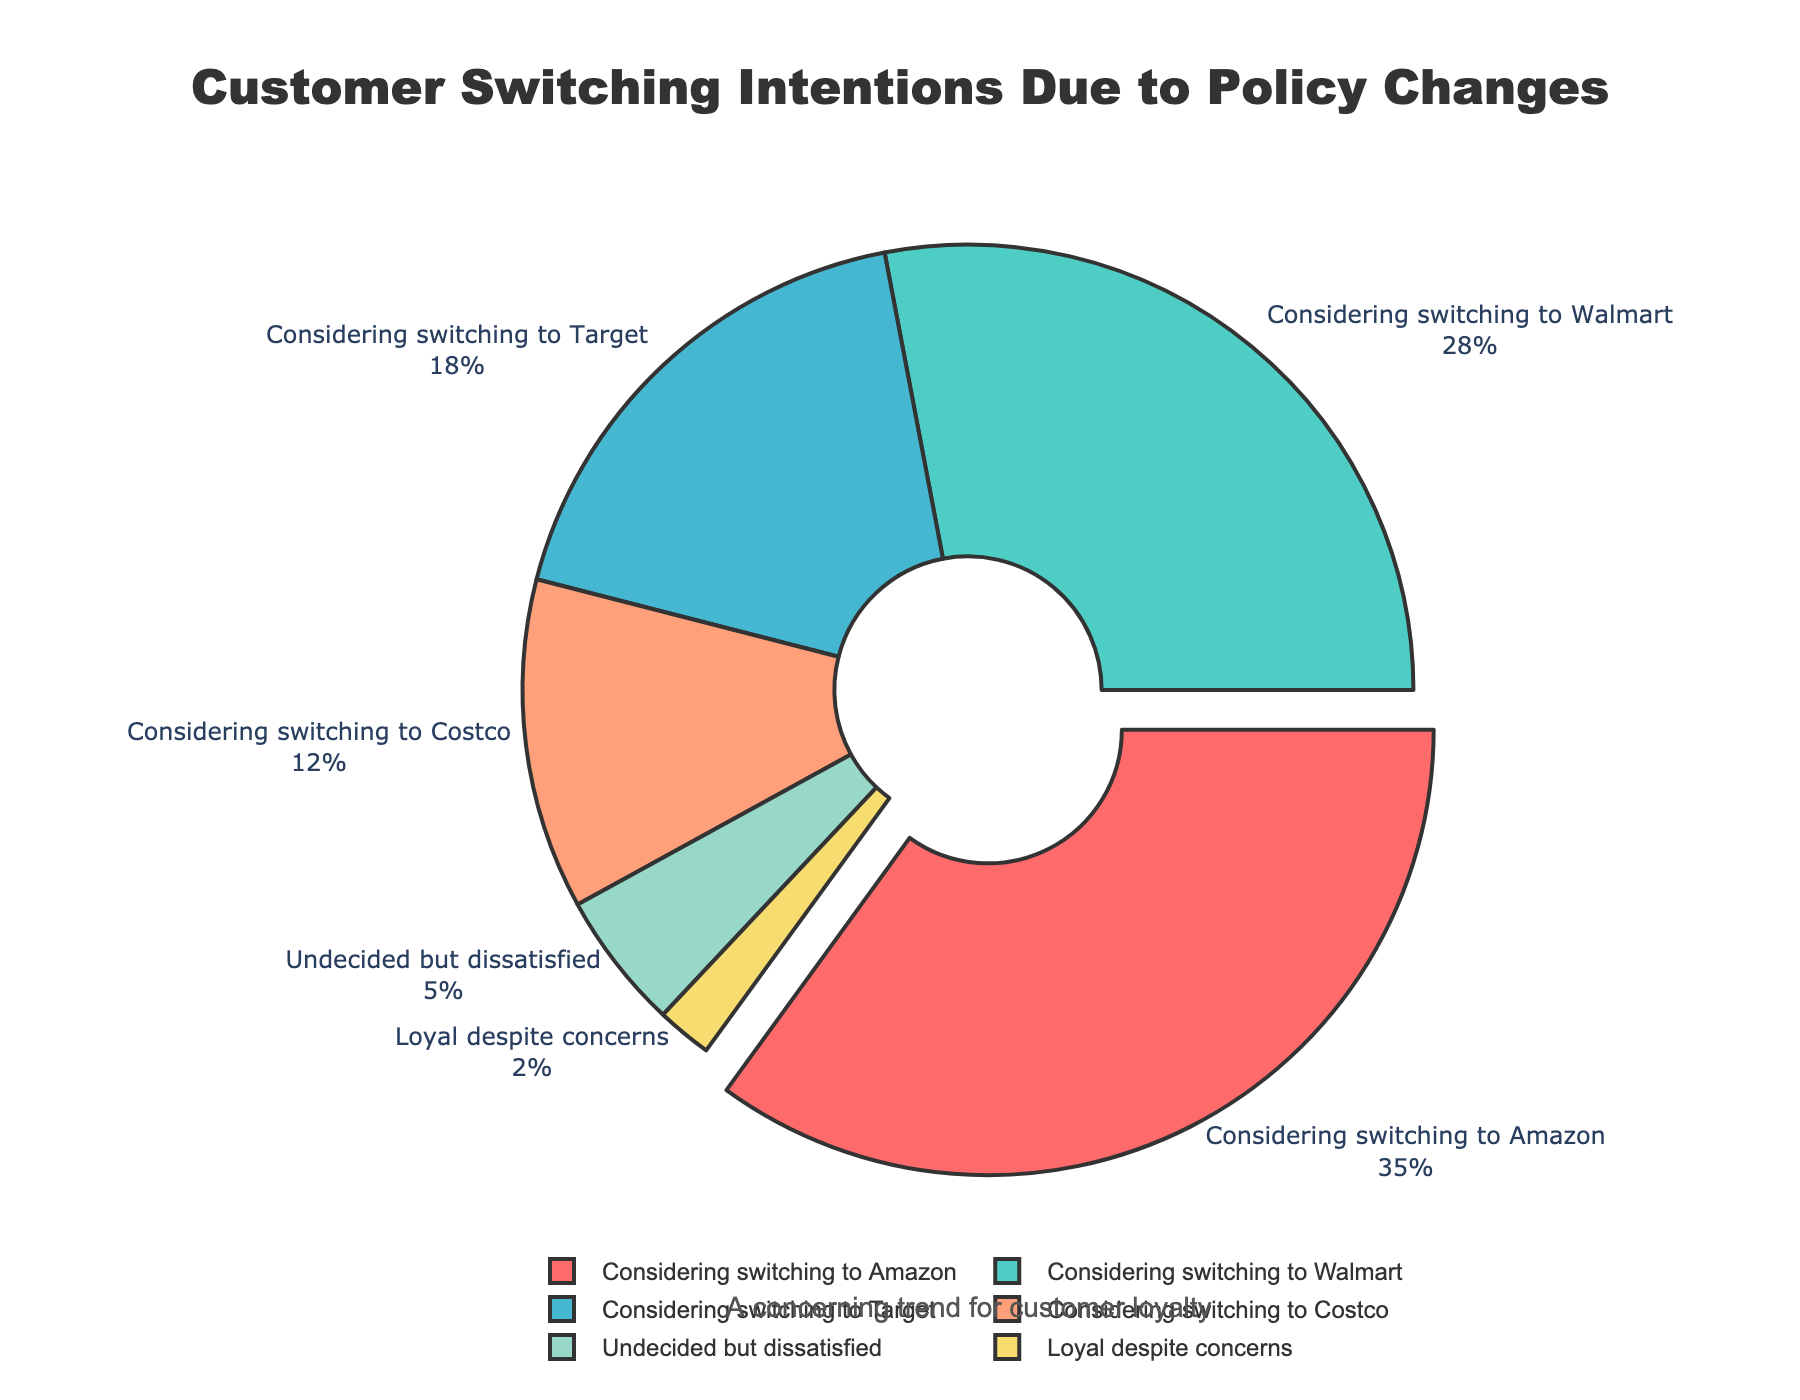What's the largest percentage of customers considering switching to a competitor? Looking at the pie chart, the largest segment represents 35%, labeled "Considering switching to Amazon." This is visibly larger than any other segment.
Answer: 35% Which companies have more than 20% of customers considering switching to them? The pie chart shows that "Considering switching to Amazon" and "Considering switching to Walmart" are the segments that have higher percentages of 35% and 28%, respectively, both of which are more than 20%.
Answer: Amazon, Walmart How many customers are either considering switching to Target or are undecided but dissatisfied? From the pie chart, the segment "Considering switching to Target" is 18%, and "Undecided but dissatisfied" is 5%. Adding these together gives 18% + 5% = 23%.
Answer: 23% Which option has the smallest percentage of customers, and what is that percentage? The pie chart shows the smallest segment labeled "Loyal despite concerns" with 2%. Reviewing all other segments confirms this is the smallest.
Answer: Loyal despite concerns, 2% Are there more customers considering switching to Costco or those who are undecided but dissatisfied? The pie chart shows that "Considering switching to Costco" is 12% and "Undecided but dissatisfied" is 5%. Comparatively, 12% is greater than 5%.
Answer: Considering switching to Costco What is the combined percentage of customers considering switching to Amazon, Walmart, and Target? The pie chart provides the percentages of 35%, 28%, and 18% for Amazon, Walmart, and Target respectively. Adding these together gives 35% + 28% + 18% = 81%.
Answer: 81% How does the percentage of customers loyal despite concerns compare to those considering switching to Costco? The pie chart shows "Loyal despite concerns" at 2% and "Considering switching to Costco" at 12%. Therefore, 2% is significantly less than 12%.
Answer: Less What is the visual attribute (color) of the segment representing customers considering switching to Walmart? Observing the pie chart, the segment "Considering switching to Walmart" is colored green.
Answer: Green 